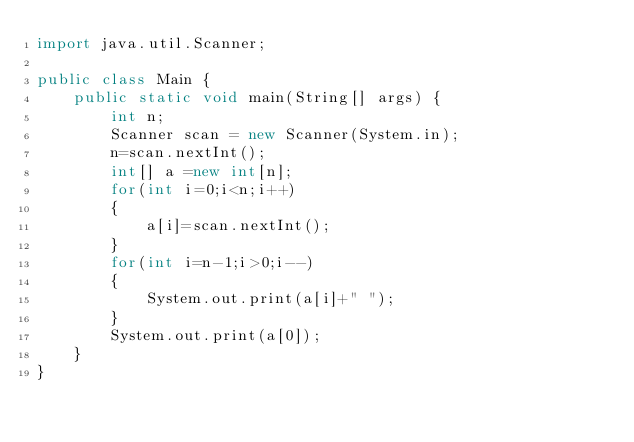<code> <loc_0><loc_0><loc_500><loc_500><_Java_>import java.util.Scanner;

public class Main {
	public static void main(String[] args) {
		int n;
		Scanner scan = new Scanner(System.in);
		n=scan.nextInt();
		int[] a =new int[n];
		for(int i=0;i<n;i++)
		{
			a[i]=scan.nextInt();
		}
		for(int i=n-1;i>0;i--)
		{
			System.out.print(a[i]+" ");
		}
		System.out.print(a[0]);
	}
}</code> 